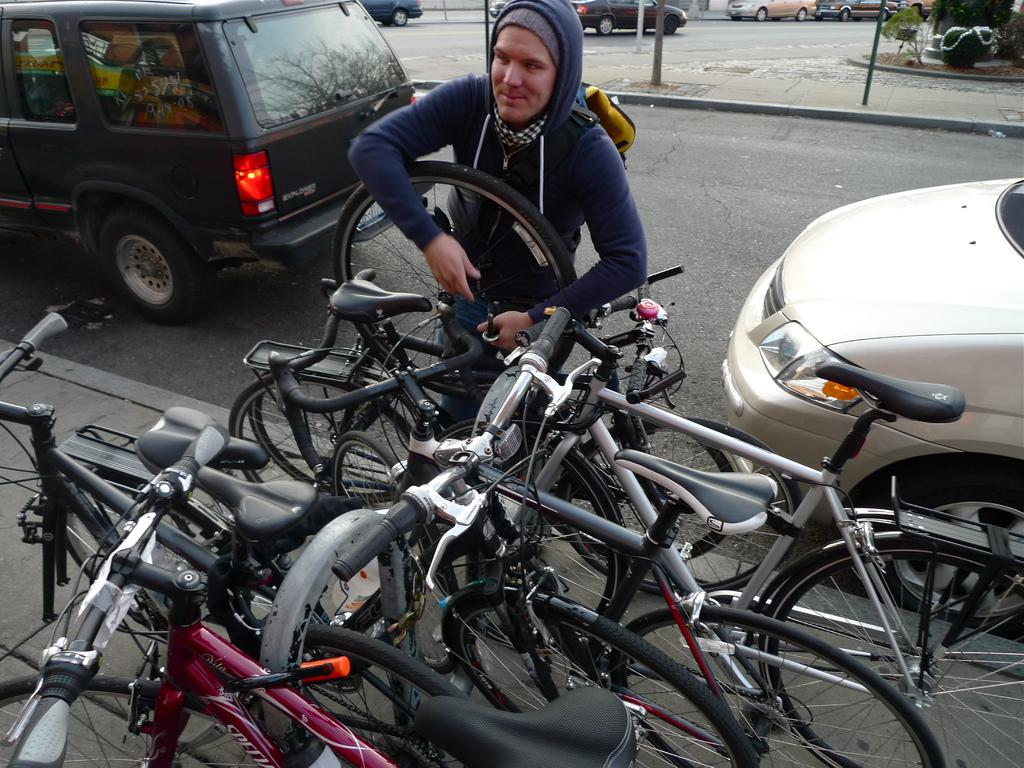What type of vehicles can be seen on the road in the image? There are cars on the road in the image. What other mode of transportation is visible in the image? There are bicycles in the image. What objects are present in the image that are not vehicles or people? There are poles and plants in the image. Can you describe the person in the image? There is a person in the image, but no specific details about their appearance or actions are provided. What type of peace can be seen in the image? There is no reference to peace in the image; it features cars, bicycles, poles, plants, and a person. Is the person in the image crying? There is no indication in the image that the person is crying; their emotional state is not described. 